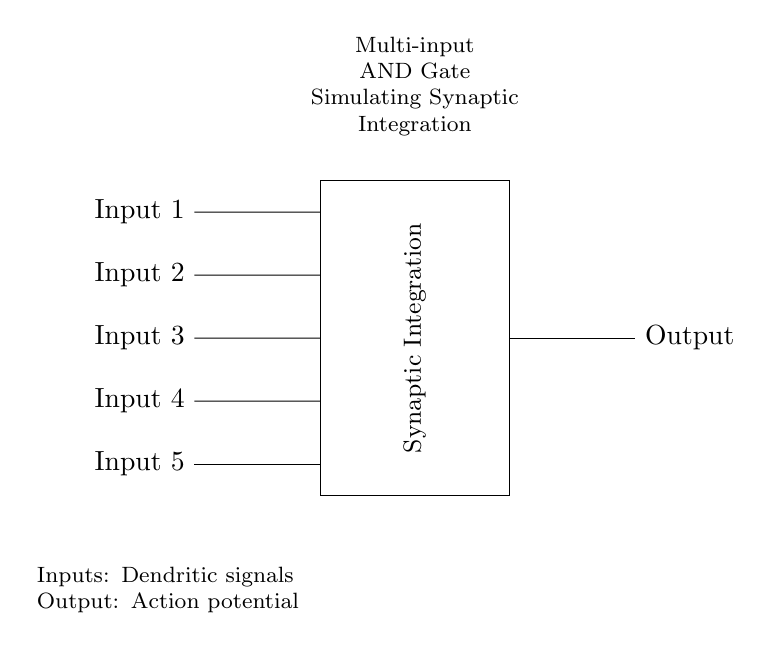What components are included in the circuit? The components in the circuit include a multi-input AND gate and multiple input signals labeled as Input 1 through Input 5.
Answer: AND gate, Input 1, Input 2, Input 3, Input 4, Input 5 What signifies the output of the circuit? The output is indicated as an "Output" signal connected to the AND gate, representing the action potential resulting from synaptic integration.
Answer: Output How many inputs are there to the AND gate? The diagram displays five distinct input connections leading to the AND gate, which indicates that there are five inputs overall.
Answer: Five What is the purpose of the AND gate in this circuit? The AND gate's purpose is to simulate synaptic integration by processing the multiple input signals simultaneously and generating a single output if all inputs are active.
Answer: Synaptic Integration What happens when all inputs are active? When all inputs are active (high), the AND gate produces a high output, simulating an action potential in the neural network context represented by this circuit.
Answer: High output Which part of the circuit represents synaptic integration? The AND gate labeled as "Synaptic Integration" represents synaptic integration in the circuit, processing the incoming signals.
Answer: AND gate 